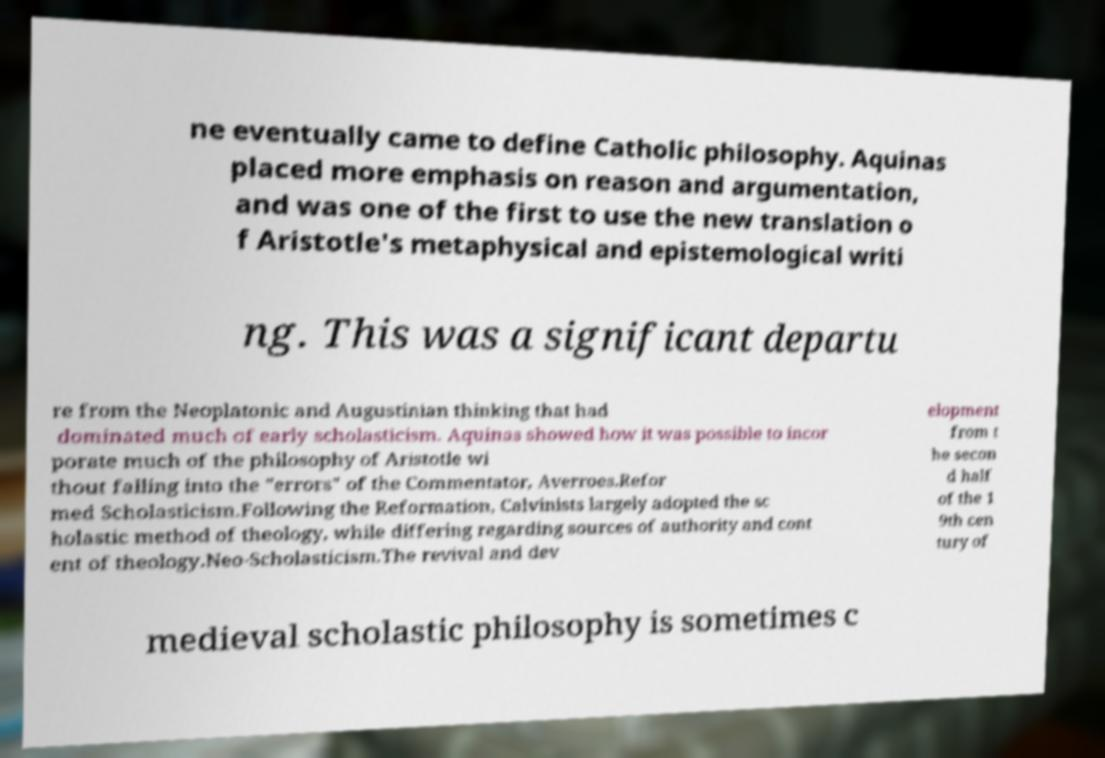Can you accurately transcribe the text from the provided image for me? ne eventually came to define Catholic philosophy. Aquinas placed more emphasis on reason and argumentation, and was one of the first to use the new translation o f Aristotle's metaphysical and epistemological writi ng. This was a significant departu re from the Neoplatonic and Augustinian thinking that had dominated much of early scholasticism. Aquinas showed how it was possible to incor porate much of the philosophy of Aristotle wi thout falling into the "errors" of the Commentator, Averroes.Refor med Scholasticism.Following the Reformation, Calvinists largely adopted the sc holastic method of theology, while differing regarding sources of authority and cont ent of theology.Neo-Scholasticism.The revival and dev elopment from t he secon d half of the 1 9th cen tury of medieval scholastic philosophy is sometimes c 